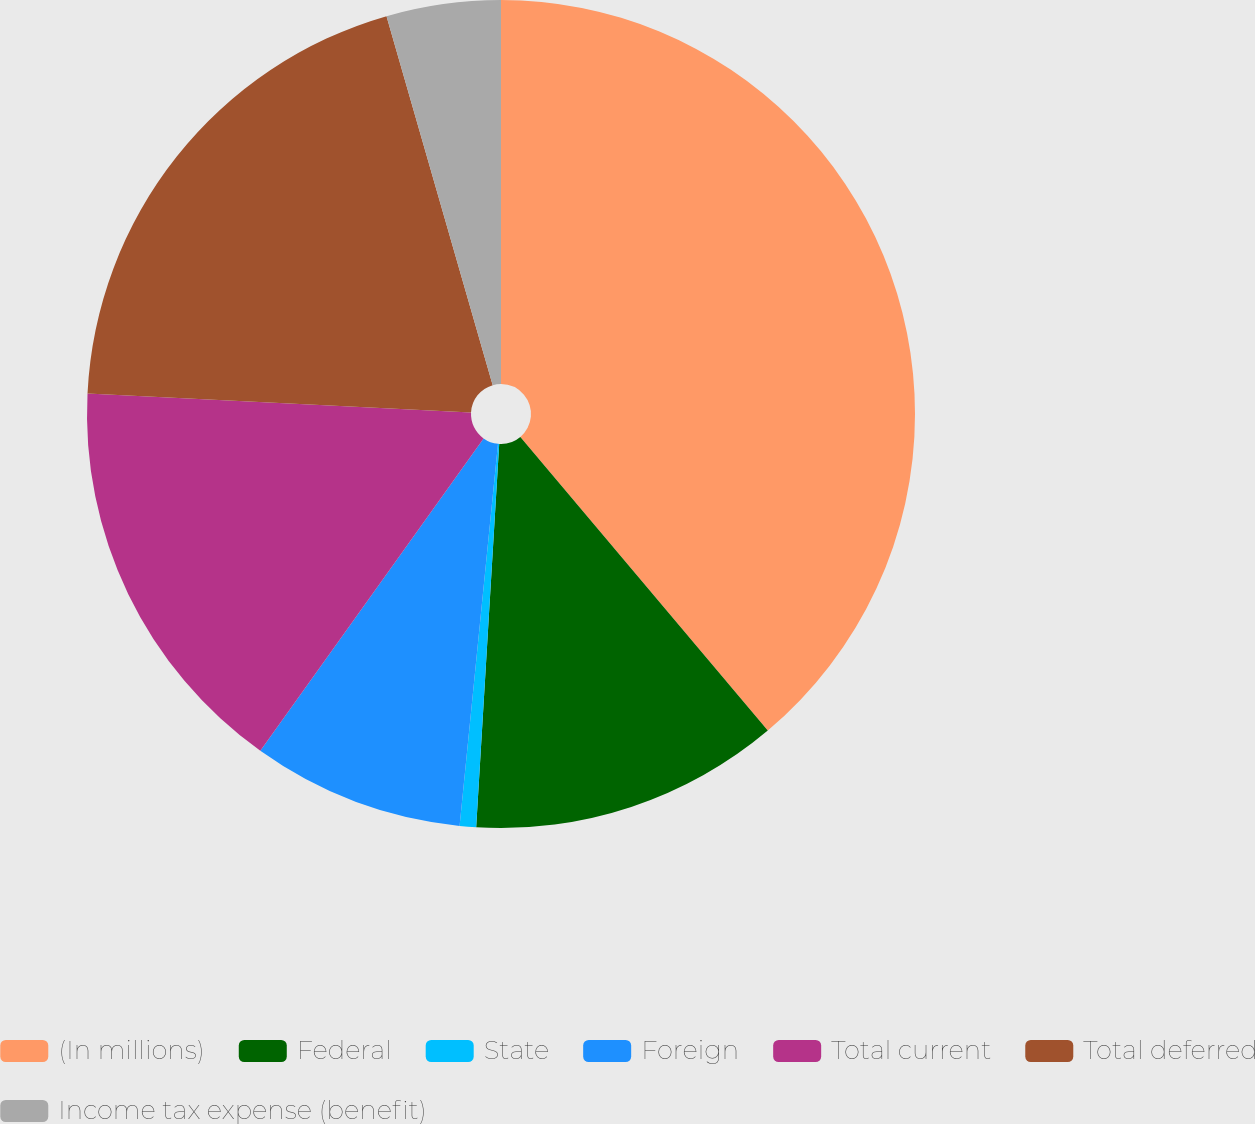Convert chart to OTSL. <chart><loc_0><loc_0><loc_500><loc_500><pie_chart><fcel>(In millions)<fcel>Federal<fcel>State<fcel>Foreign<fcel>Total current<fcel>Total deferred<fcel>Income tax expense (benefit)<nl><fcel>38.86%<fcel>12.1%<fcel>0.64%<fcel>8.28%<fcel>15.92%<fcel>19.75%<fcel>4.46%<nl></chart> 